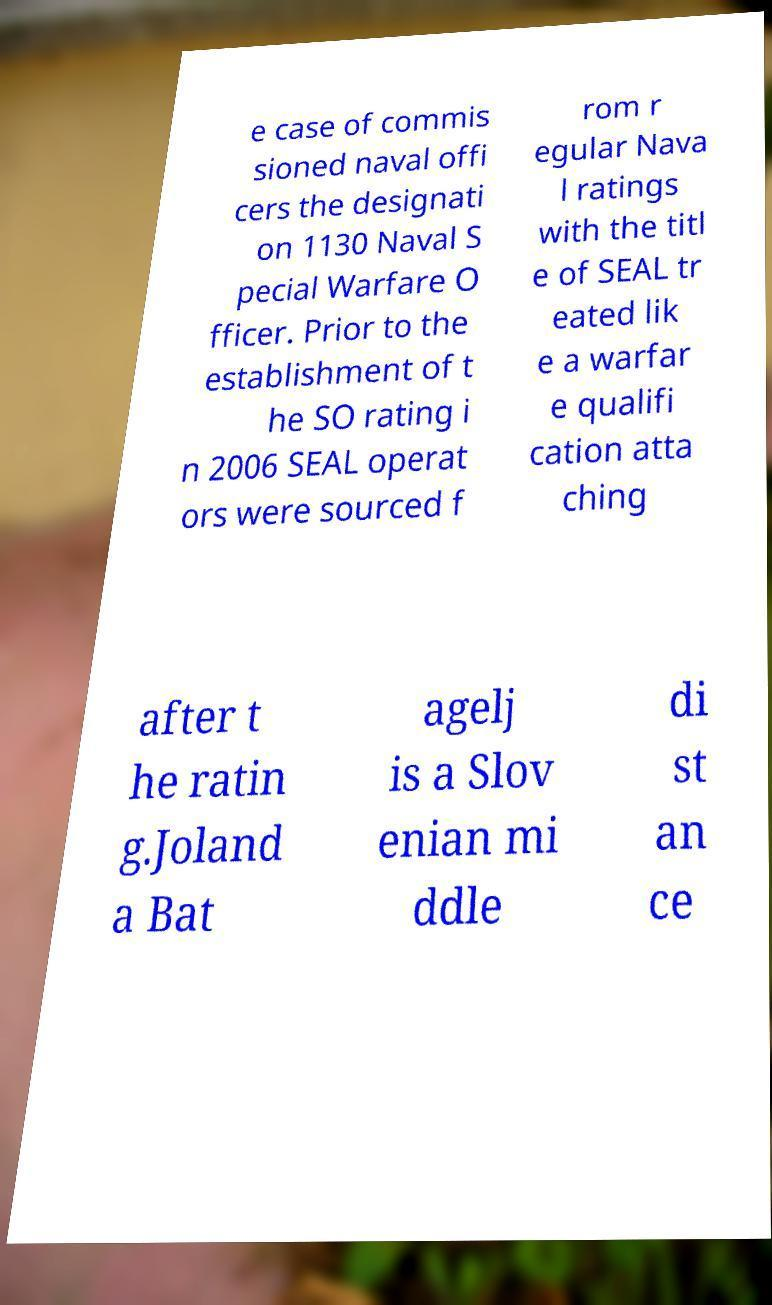What messages or text are displayed in this image? I need them in a readable, typed format. e case of commis sioned naval offi cers the designati on 1130 Naval S pecial Warfare O fficer. Prior to the establishment of t he SO rating i n 2006 SEAL operat ors were sourced f rom r egular Nava l ratings with the titl e of SEAL tr eated lik e a warfar e qualifi cation atta ching after t he ratin g.Joland a Bat agelj is a Slov enian mi ddle di st an ce 